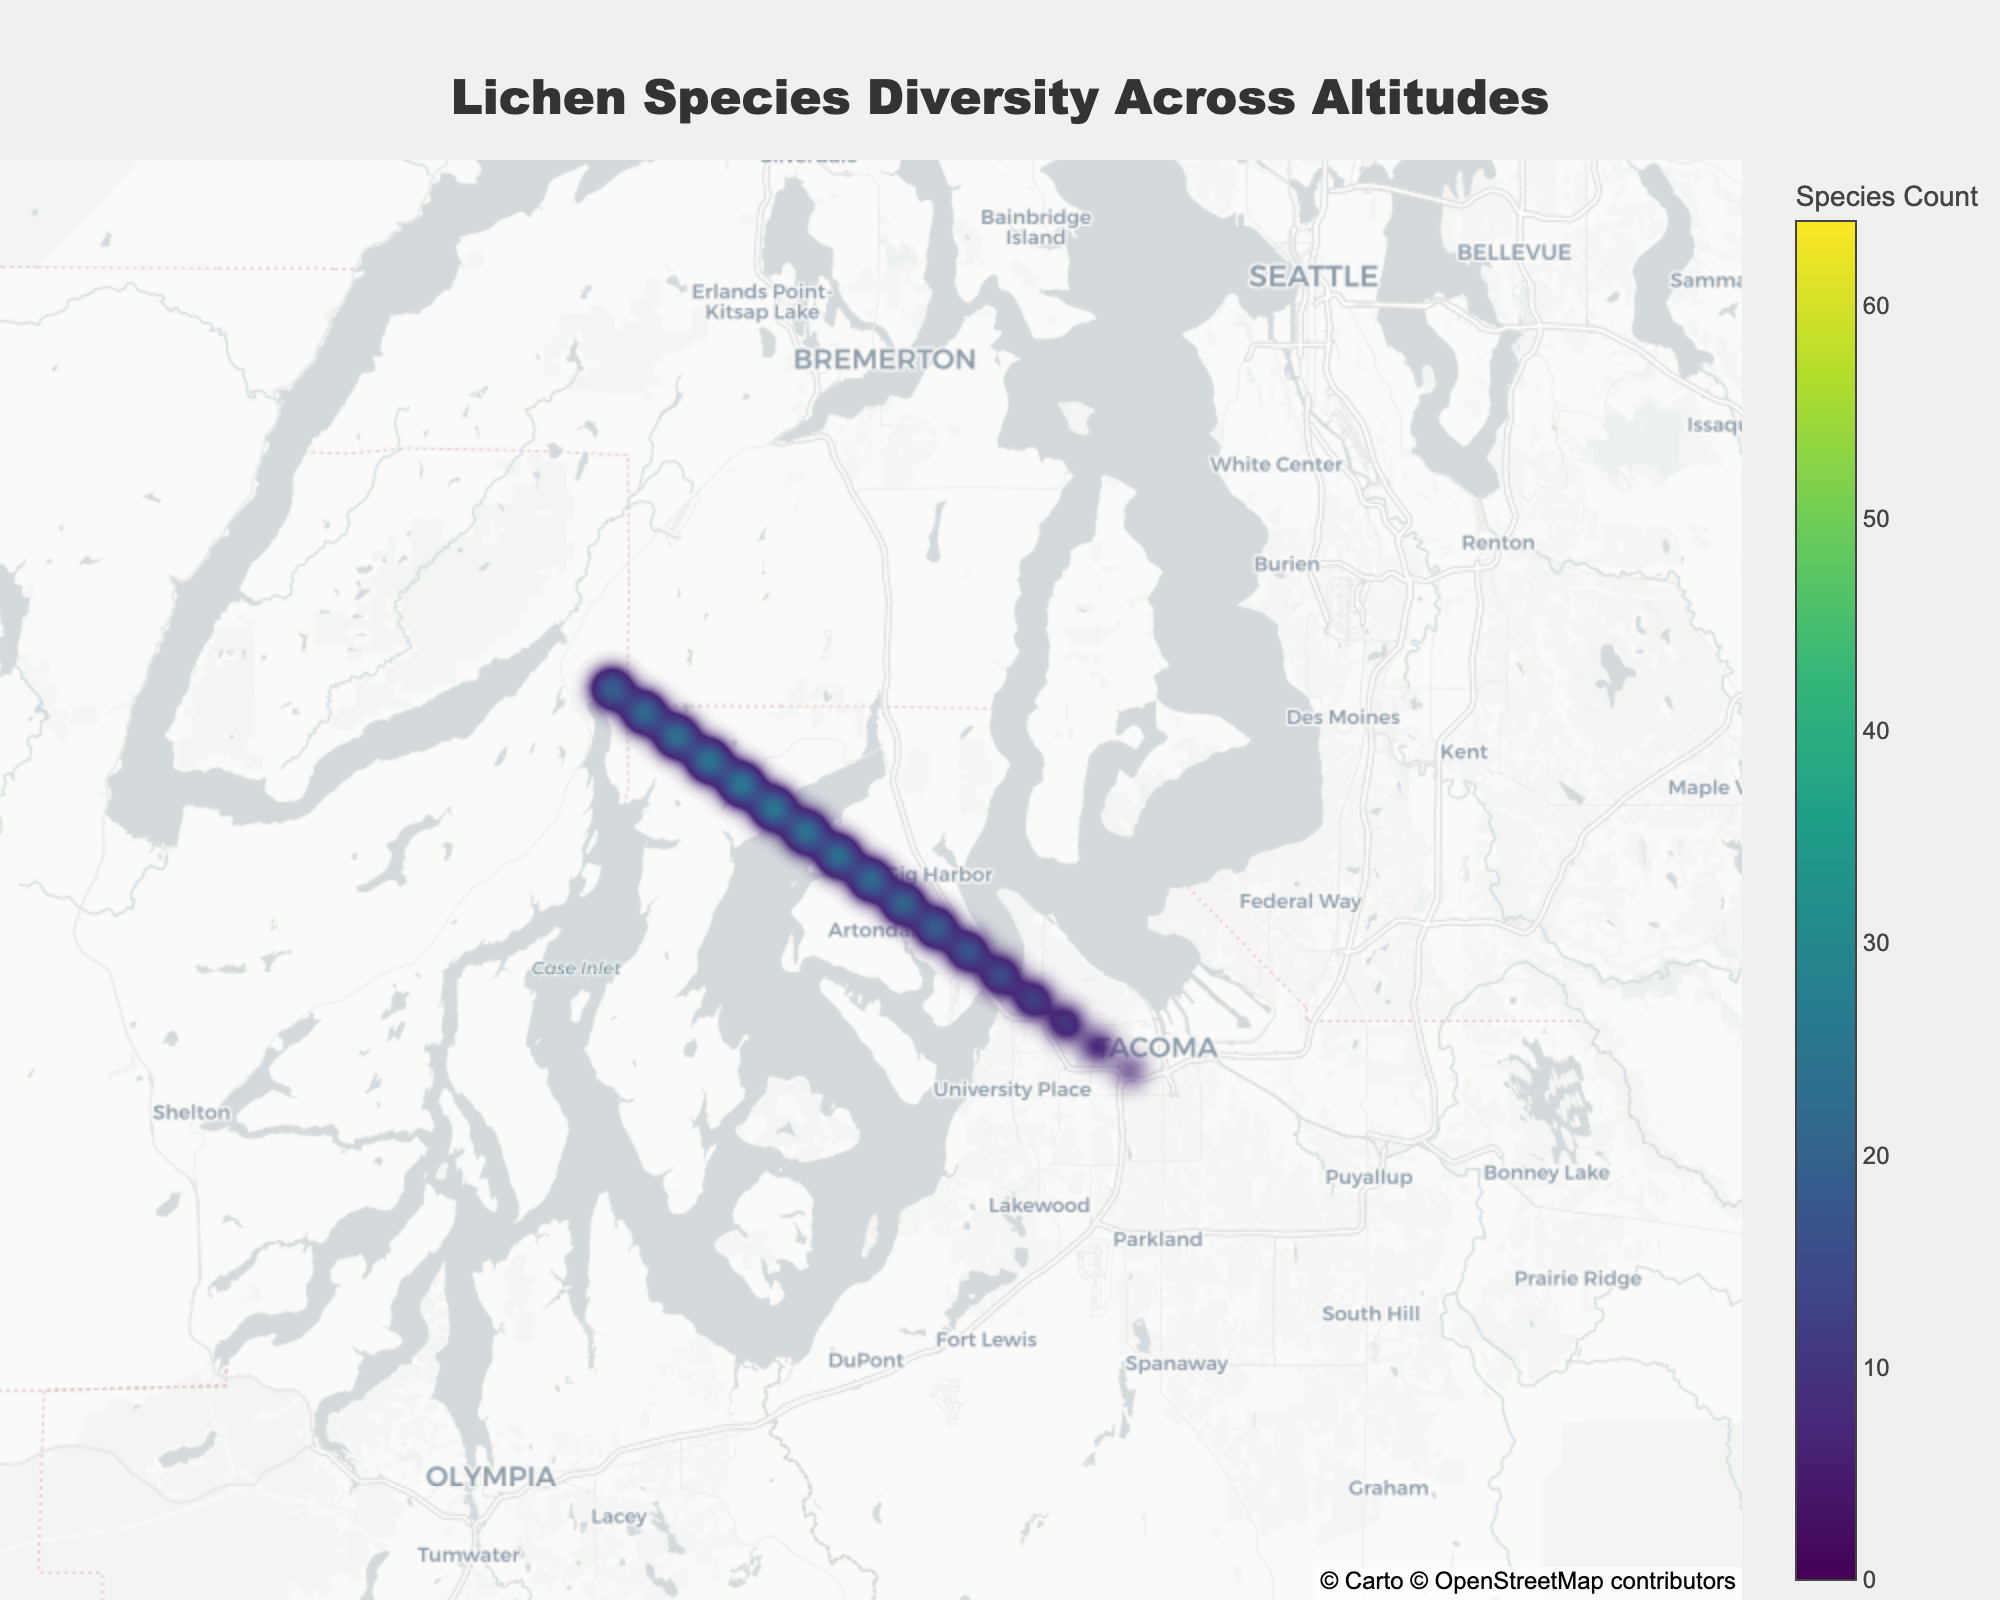What is the title of the figure? The title of the figure can be found at the top, and it provides an overall summary of what the plot reveals. The text is large and centrally placed.
Answer: Lichen Species Diversity Across Altitudes What colors are used to represent the species count in the plot? The colors representing the species count are shown in the color scale on the right side of the figure, ranging from the lowest to the highest values.
Answer: Viridis colorscale What is the altitude where the highest species count is observed? By looking at the annotations on the figure, we can find the altitude corresponding to the highest values of species count.
Answer: 1900m At which latitude and longitude does the maximum species diversity occur? The highest species count can be identified by locating the darkest (most saturated) hexes on the map, and near them is an annotation indicating the precise geographical coordinates.
Answer: Approximately 47.3678, -122.7234 How does species count change with increasing altitude? Observing the trend in species count against increasing altitudes (as indicated by annotations) from lowest to highest points in the figure, one can infer if species count increases or decreases with altitude.
Answer: Generally increases up to 1900m, then decreases What's the overall range of altitudes represented in the plot? By checking the lowest and highest altitude values annotated across the figure, we determine the range of altitudes present.
Answer: 100m to 2500m Which altitude range shows the most dramatic increase in species count? By comparing species counts at consecutive altitude annotations, the altitude range with the sharpest change in one step can be determined.
Answer: 850m to 1300m What does the color of the hexagons represent in the plot? The hexagon color directly maps to a value shown in the colorbar, indicating the number of lichen species at various locations.
Answer: Species count Which altitude has the closest species count to 50? By noting the annotated altitudes and comparing them to their species counts, the altitude nearest to a count of 50 can be selected.
Answer: 2500m How are the geographical coordinates distributed across the plot? Observing the scattered placement of the hexagons and the annotations, the spatial distribution of latitude and longitude points is seen.
Answer: Geographical coordinates are well-dispersed 